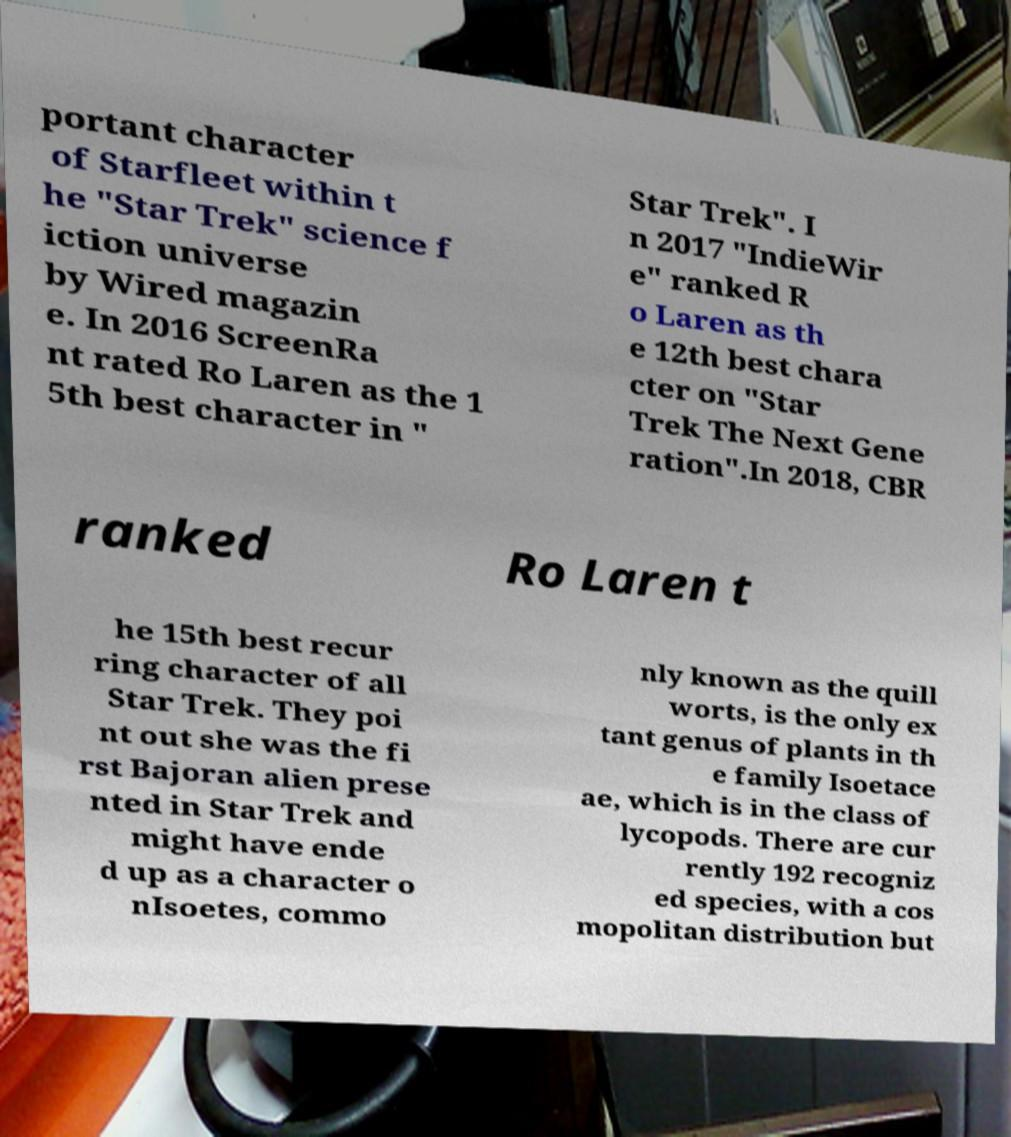Please read and relay the text visible in this image. What does it say? portant character of Starfleet within t he "Star Trek" science f iction universe by Wired magazin e. In 2016 ScreenRa nt rated Ro Laren as the 1 5th best character in " Star Trek". I n 2017 "IndieWir e" ranked R o Laren as th e 12th best chara cter on "Star Trek The Next Gene ration".In 2018, CBR ranked Ro Laren t he 15th best recur ring character of all Star Trek. They poi nt out she was the fi rst Bajoran alien prese nted in Star Trek and might have ende d up as a character o nIsoetes, commo nly known as the quill worts, is the only ex tant genus of plants in th e family Isoetace ae, which is in the class of lycopods. There are cur rently 192 recogniz ed species, with a cos mopolitan distribution but 